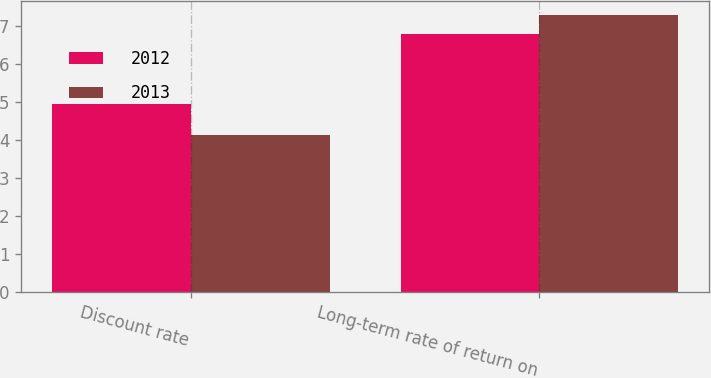<chart> <loc_0><loc_0><loc_500><loc_500><stacked_bar_chart><ecel><fcel>Discount rate<fcel>Long-term rate of return on<nl><fcel>2012<fcel>4.96<fcel>6.8<nl><fcel>2013<fcel>4.14<fcel>7.3<nl></chart> 